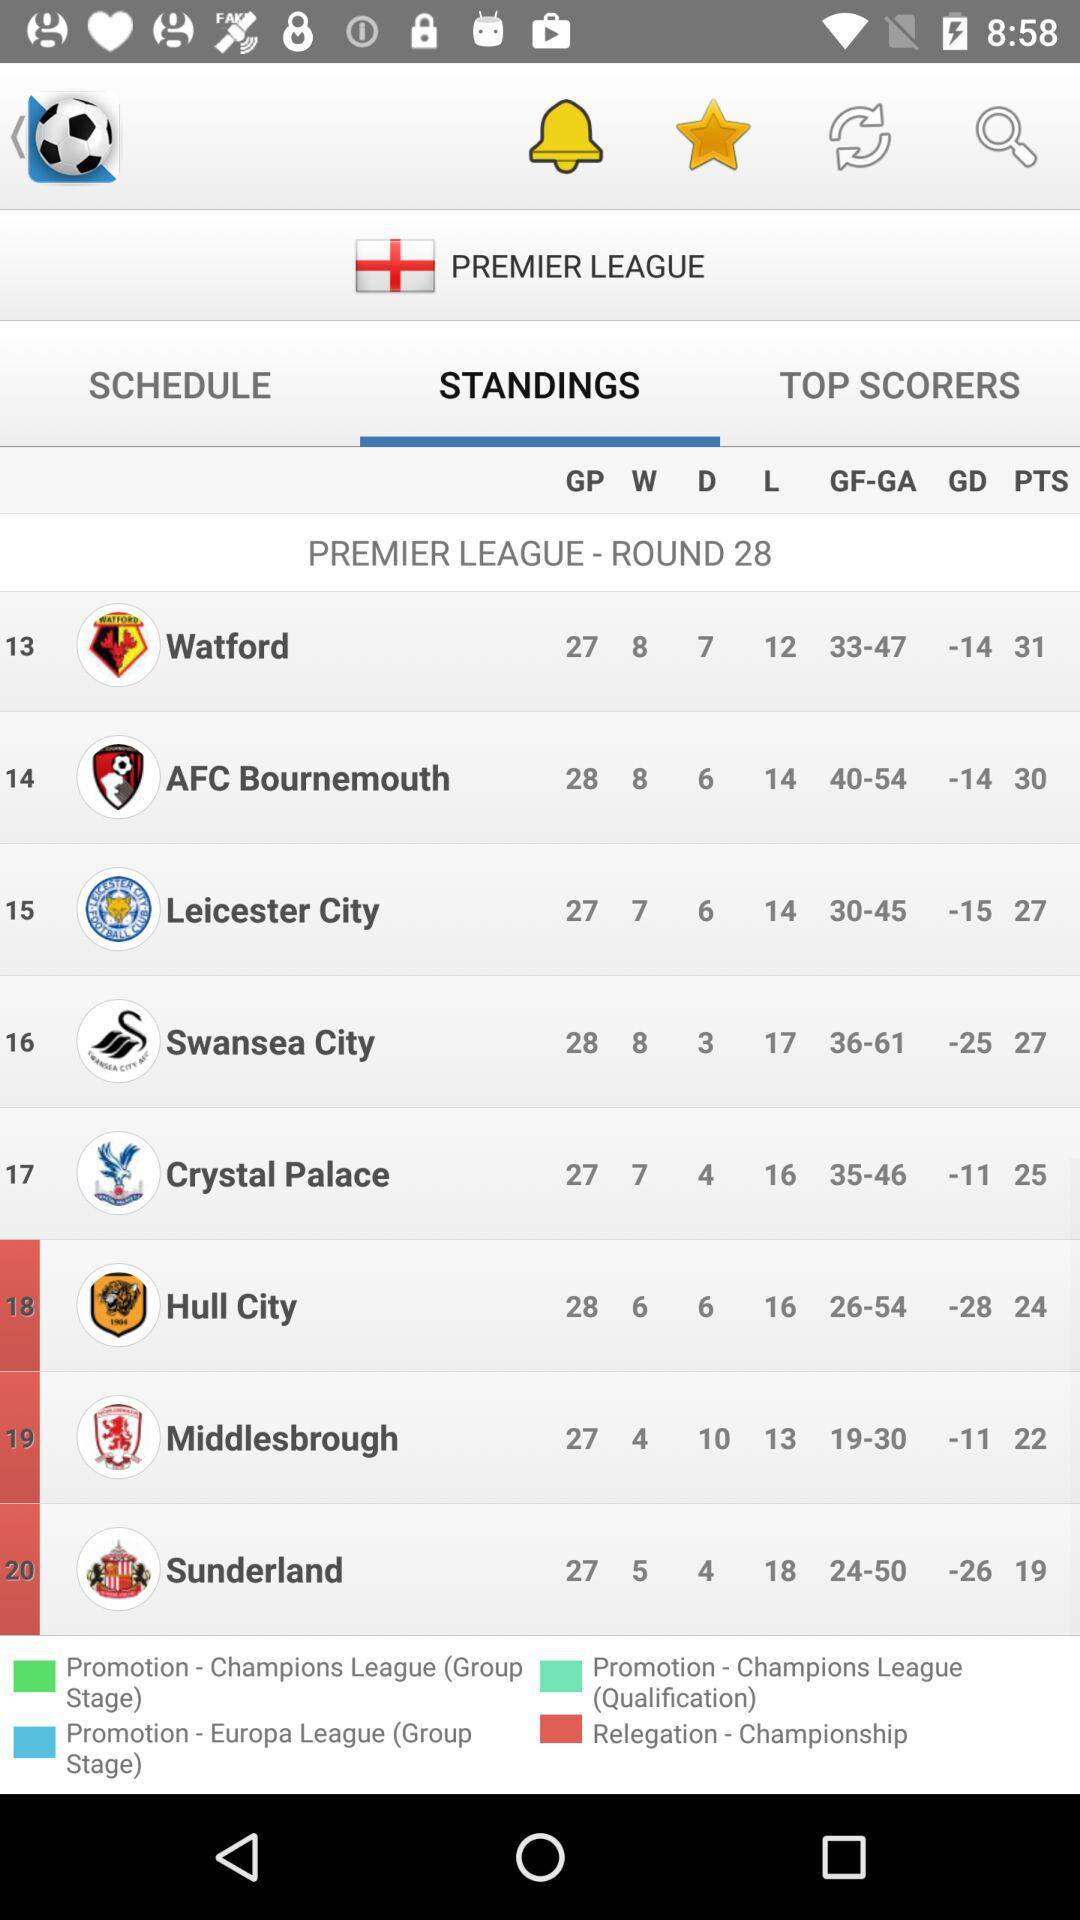What is the name of the league? The name of the league is "PREMIER LEAGUE". 